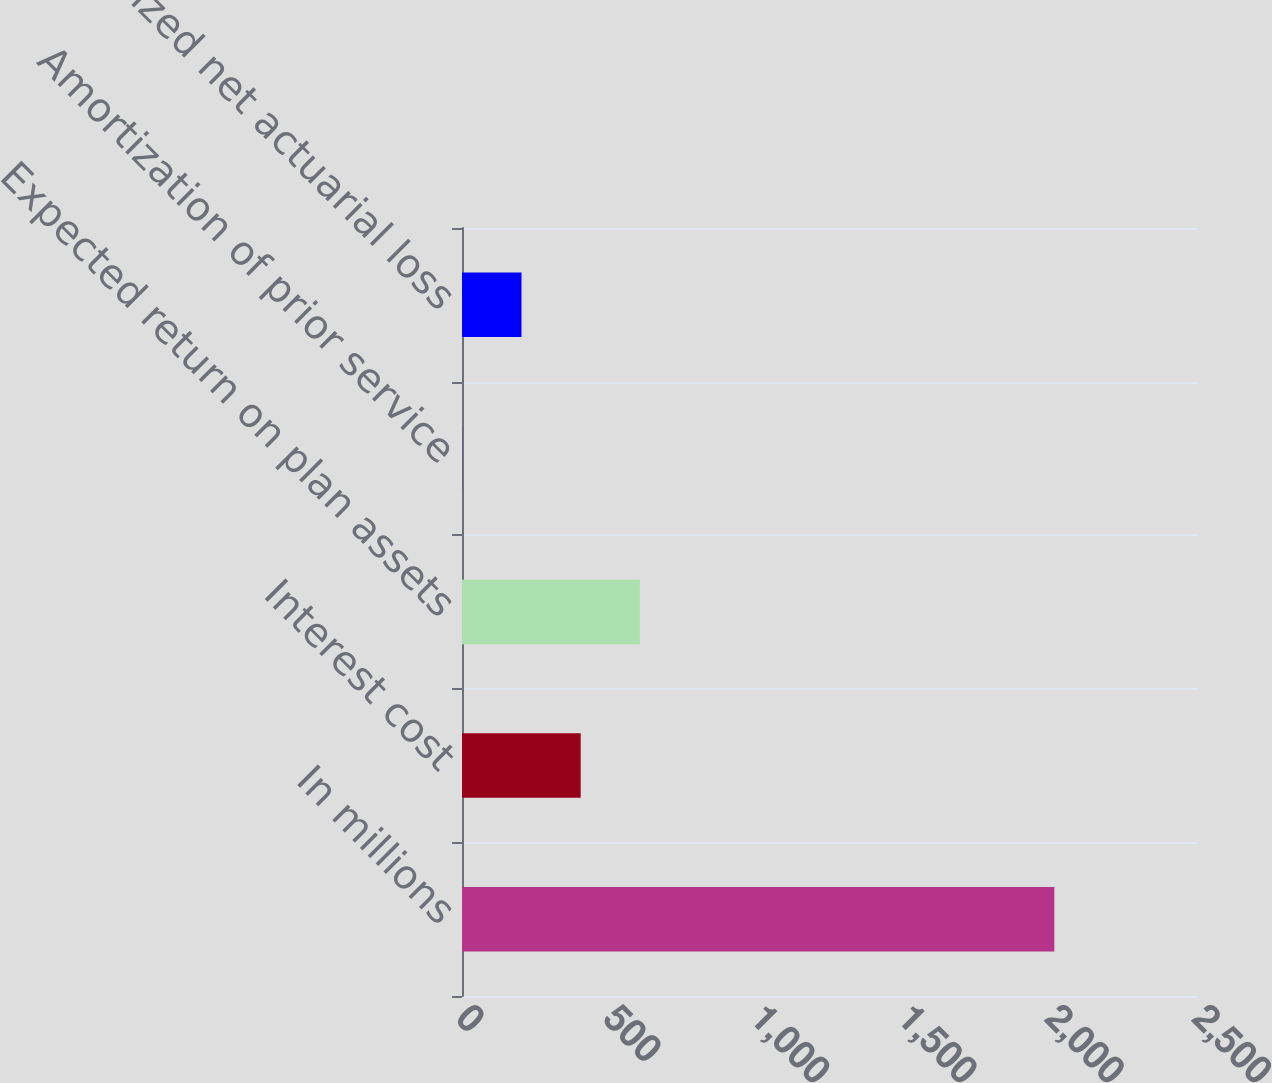Convert chart to OTSL. <chart><loc_0><loc_0><loc_500><loc_500><bar_chart><fcel>In millions<fcel>Interest cost<fcel>Expected return on plan assets<fcel>Amortization of prior service<fcel>Recognized net actuarial loss<nl><fcel>2012<fcel>403.2<fcel>604.3<fcel>1<fcel>202.1<nl></chart> 